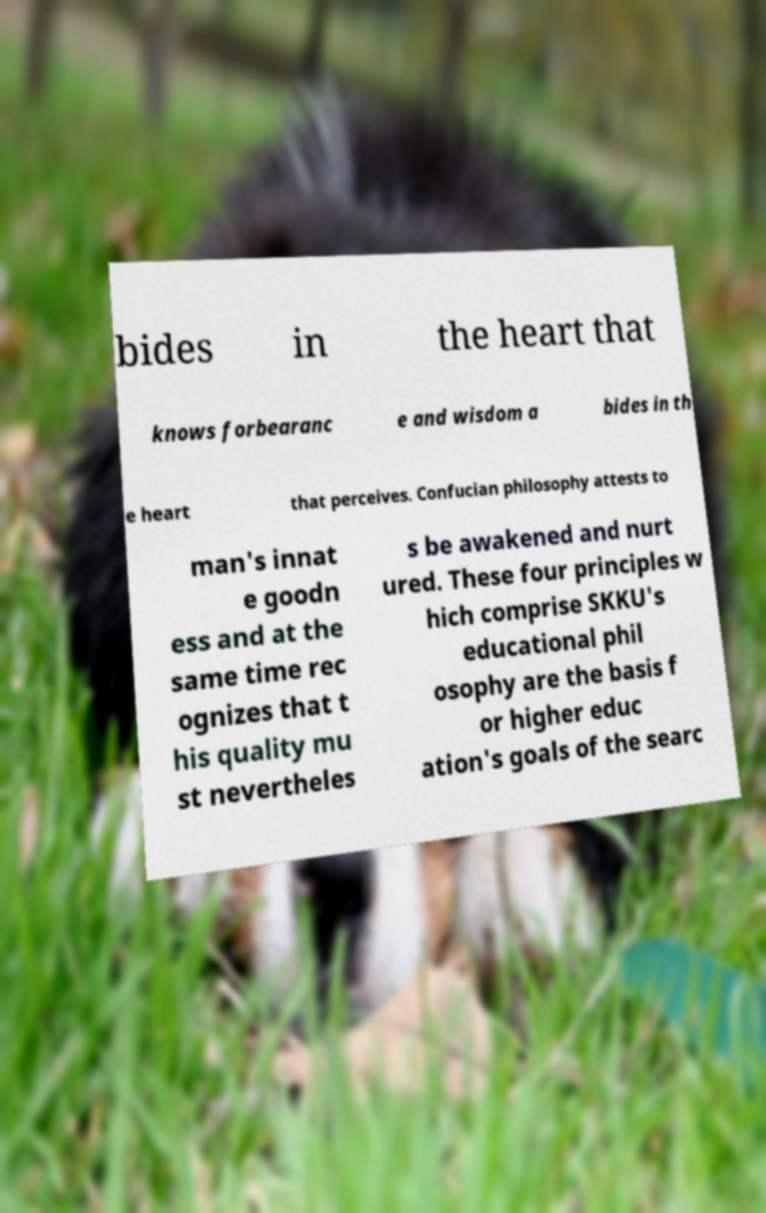Please identify and transcribe the text found in this image. bides in the heart that knows forbearanc e and wisdom a bides in th e heart that perceives. Confucian philosophy attests to man's innat e goodn ess and at the same time rec ognizes that t his quality mu st nevertheles s be awakened and nurt ured. These four principles w hich comprise SKKU's educational phil osophy are the basis f or higher educ ation's goals of the searc 